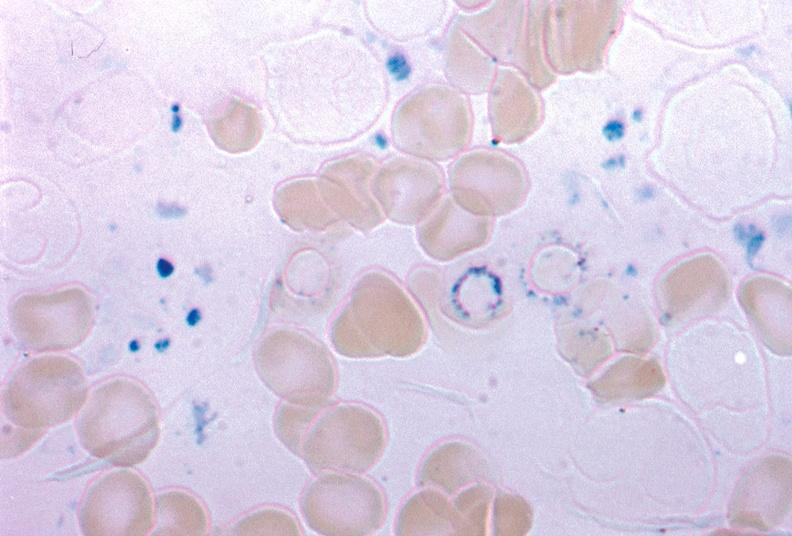s complex craniofacial abnormalities present?
Answer the question using a single word or phrase. No 